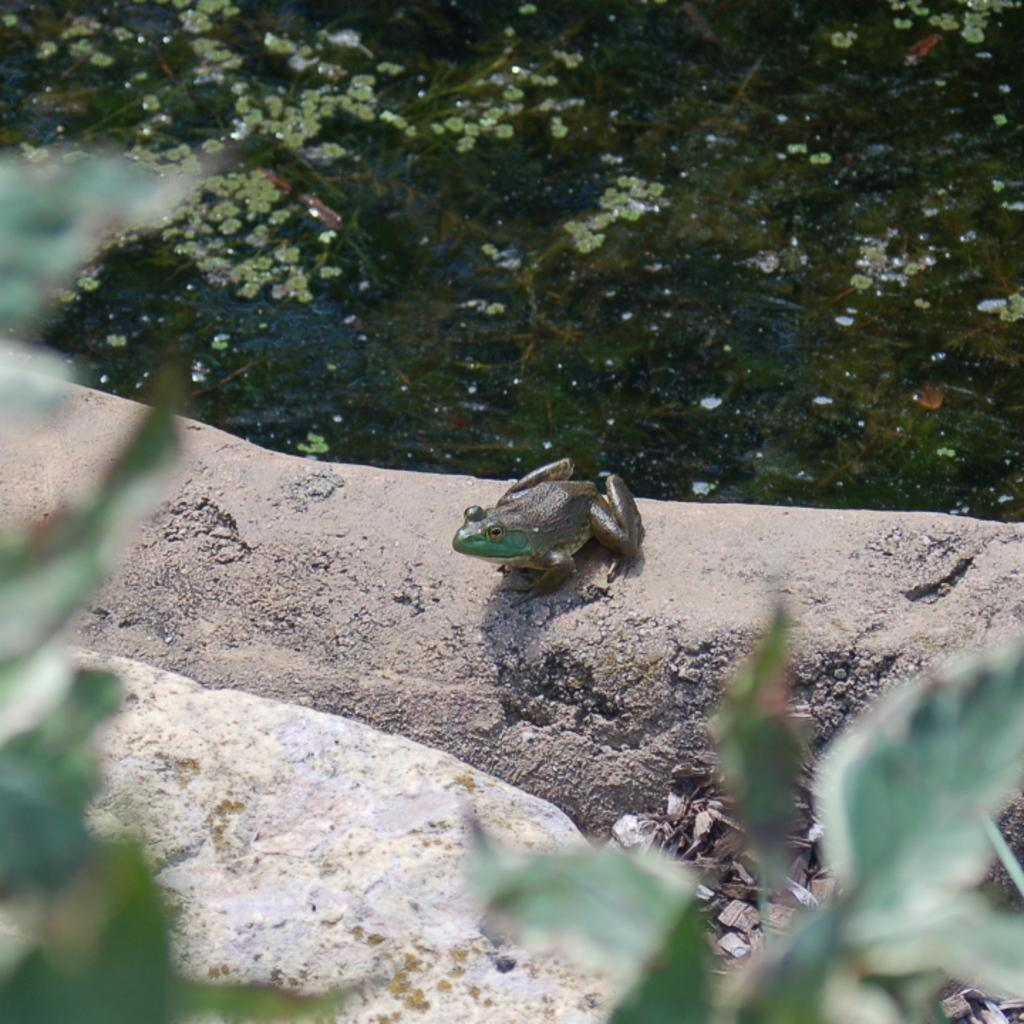What type of living organism can be seen in the image? There is a frog on the ground in the image. What other objects or elements are present in the image? There is a plant and a rock in the image. What can be seen in the background of the image? There is water visible in the background of the image. What type of nut is being distributed by the fish in the image? There is no fish present in the image, and therefore no nut distribution can be observed. 